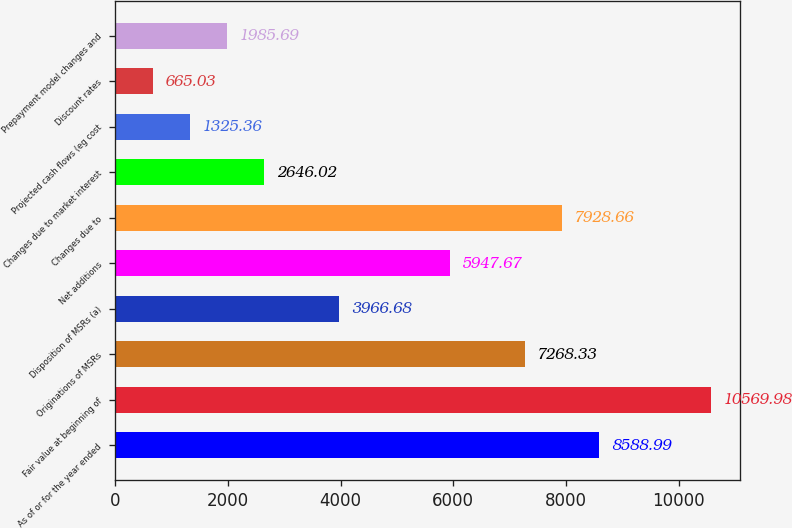Convert chart to OTSL. <chart><loc_0><loc_0><loc_500><loc_500><bar_chart><fcel>As of or for the year ended<fcel>Fair value at beginning of<fcel>Originations of MSRs<fcel>Disposition of MSRs (a)<fcel>Net additions<fcel>Changes due to<fcel>Changes due to market interest<fcel>Projected cash flows (eg cost<fcel>Discount rates<fcel>Prepayment model changes and<nl><fcel>8588.99<fcel>10570<fcel>7268.33<fcel>3966.68<fcel>5947.67<fcel>7928.66<fcel>2646.02<fcel>1325.36<fcel>665.03<fcel>1985.69<nl></chart> 